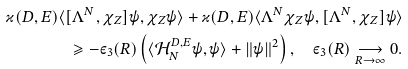Convert formula to latex. <formula><loc_0><loc_0><loc_500><loc_500>\varkappa ( D , E ) \langle [ \Lambda ^ { N } , \chi _ { Z } ] \psi , \chi _ { Z } \psi \rangle + \varkappa ( D , E ) \langle \Lambda ^ { N } \chi _ { Z } \psi , [ \Lambda ^ { N } , \chi _ { Z } ] \psi \rangle \\ \geqslant - \varepsilon _ { 3 } ( R ) \left ( \langle \mathcal { H } _ { N } ^ { D , E } \psi , \psi \rangle + \| \psi \| ^ { 2 } \right ) , \quad \varepsilon _ { 3 } ( R ) \underset { R \to \infty } { \longrightarrow } 0 .</formula> 